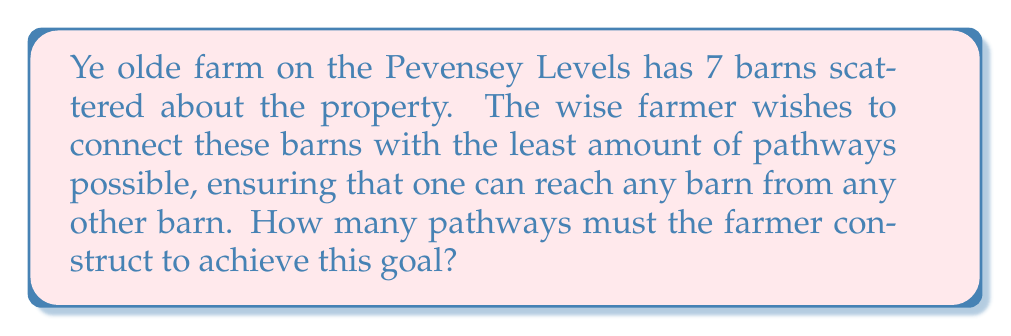Show me your answer to this math problem. This problem can be solved using the concept of a minimum spanning tree in graph theory. Here's how we approach it:

1. Each barn represents a vertex in a graph.
2. The pathways between barns represent edges in the graph.
3. We need to find the minimum number of edges that connect all vertices.

The minimum number of edges needed to connect $n$ vertices in a graph is always $n-1$. This creates a tree structure (a connected graph with no cycles) that spans all vertices.

In this case:
* Number of barns (vertices) = 7
* Minimum number of pathways (edges) = $7 - 1 = 6$

We can prove this mathematically:

Let $G$ be a connected graph with $n$ vertices.
* If $G$ has fewer than $n-1$ edges, it cannot be connected (as it would have more than one component).
* If $G$ has exactly $n-1$ edges and is connected, it must be a tree (adding any edge would create a cycle).
* If $G$ has more than $n-1$ edges, it must contain a cycle, which is not minimal.

Therefore, the minimum number of edges to connect $n$ vertices is always $n-1$.

[asy]
unitsize(30);
pair[] A = new pair[7];
for(int i=0; i<7; ++i) A[i] = dir(360/7*i);
for(int i=0; i<6; ++i) draw(A[i]--A[i+1], blue);
for(int i=0; i<7; ++i) dot(A[i], red+3);
label("Barn 1", A[0], N);
label("Barn 2", A[1], NE);
label("Barn 3", A[2], SE);
label("Barn 4", A[3], S);
label("Barn 5", A[4], SW);
label("Barn 6", A[5], NW);
label("Barn 7", A[6], N);
[/asy]

The diagram above illustrates a possible configuration of 7 barns connected by 6 pathways, forming a minimum spanning tree.
Answer: The farmer must construct 6 pathways to connect all 7 barns with the minimum number of connections. 